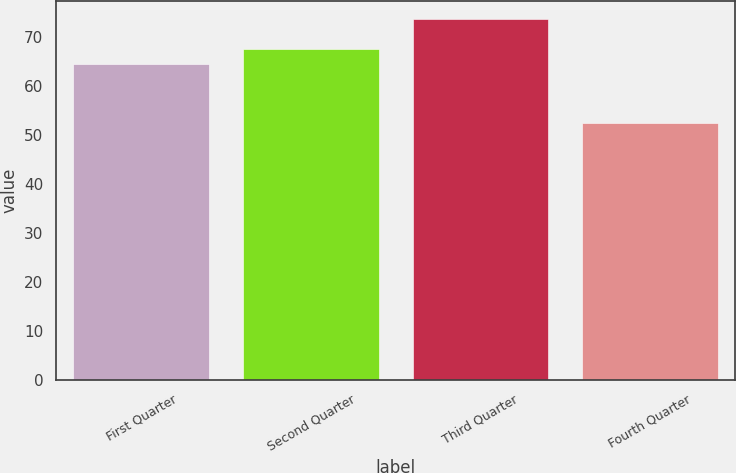<chart> <loc_0><loc_0><loc_500><loc_500><bar_chart><fcel>First Quarter<fcel>Second Quarter<fcel>Third Quarter<fcel>Fourth Quarter<nl><fcel>64.49<fcel>67.45<fcel>73.59<fcel>52.36<nl></chart> 